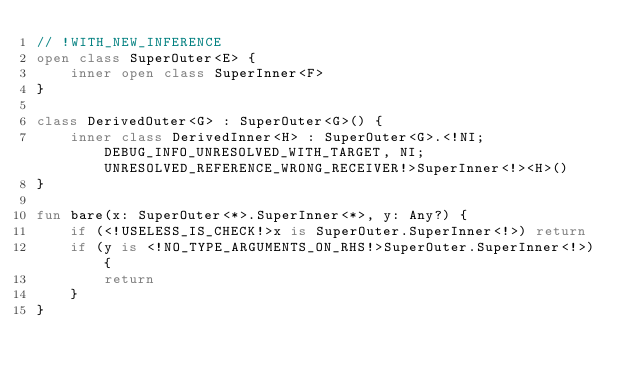<code> <loc_0><loc_0><loc_500><loc_500><_Kotlin_>// !WITH_NEW_INFERENCE
open class SuperOuter<E> {
    inner open class SuperInner<F>
}

class DerivedOuter<G> : SuperOuter<G>() {
    inner class DerivedInner<H> : SuperOuter<G>.<!NI;DEBUG_INFO_UNRESOLVED_WITH_TARGET, NI;UNRESOLVED_REFERENCE_WRONG_RECEIVER!>SuperInner<!><H>()
}

fun bare(x: SuperOuter<*>.SuperInner<*>, y: Any?) {
    if (<!USELESS_IS_CHECK!>x is SuperOuter.SuperInner<!>) return
    if (y is <!NO_TYPE_ARGUMENTS_ON_RHS!>SuperOuter.SuperInner<!>) {
        return
    }
}
</code> 